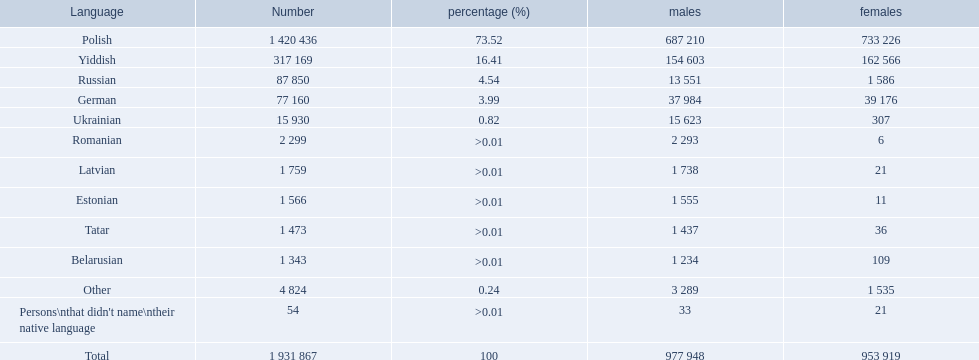How many languages are there? Polish, Yiddish, Russian, German, Ukrainian, Romanian, Latvian, Estonian, Tatar, Belarusian. Which language do more people speak? Polish. What is the fraction of polish speakers? 73.52. What is the succeeding highest fraction of speakers? 16.41. What language is associated with this fraction? Yiddish. 